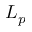<formula> <loc_0><loc_0><loc_500><loc_500>L _ { p }</formula> 